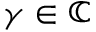<formula> <loc_0><loc_0><loc_500><loc_500>\gamma \in \mathbb { C }</formula> 